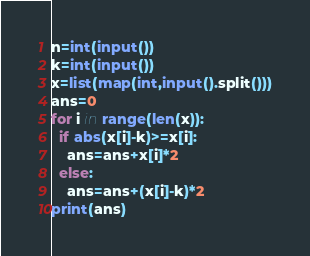Convert code to text. <code><loc_0><loc_0><loc_500><loc_500><_Python_>n=int(input())
k=int(input())
x=list(map(int,input().split()))
ans=0
for i in range(len(x)):
  if abs(x[i]-k)>=x[i]:
    ans=ans+x[i]*2
  else:
    ans=ans+(x[i]-k)*2
print(ans)</code> 